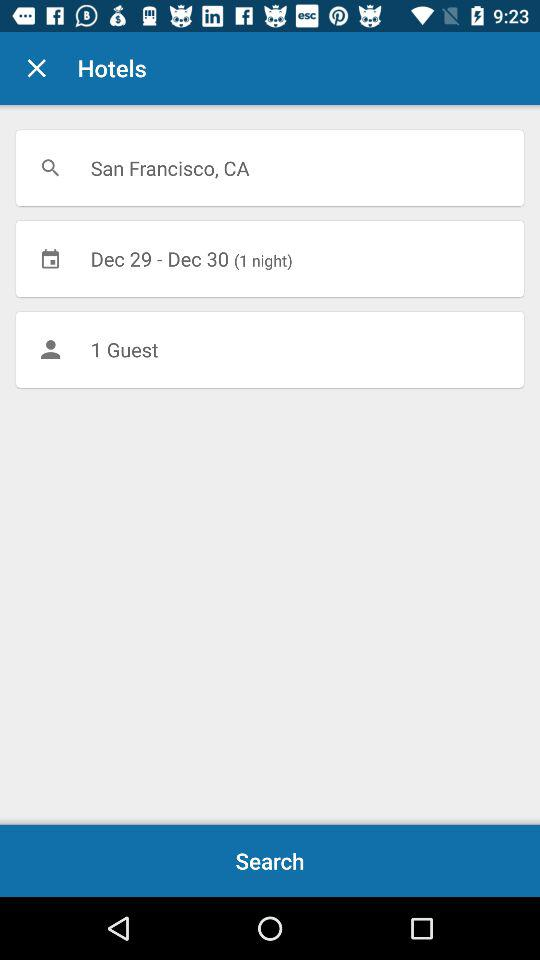What is the selected date for the hotel search? The selected dates are December 29 and December 30. 